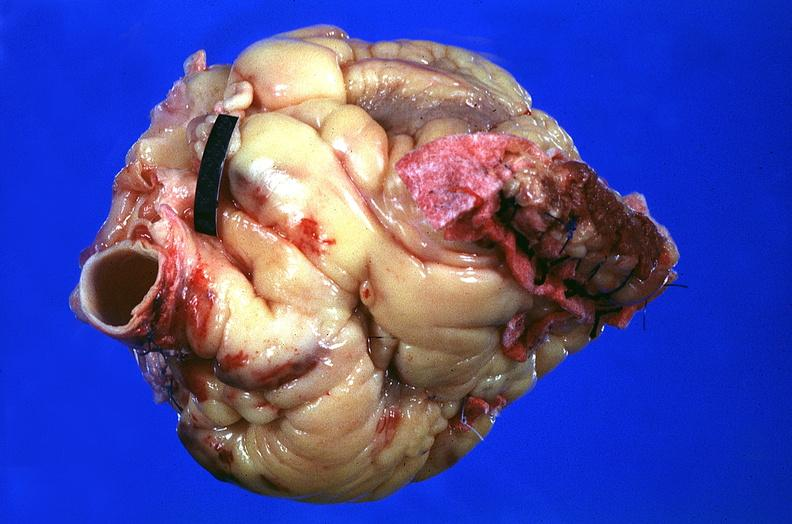does this image show heart, myocardial infarction, surgery to repair interventricular septum rupture?
Answer the question using a single word or phrase. Yes 